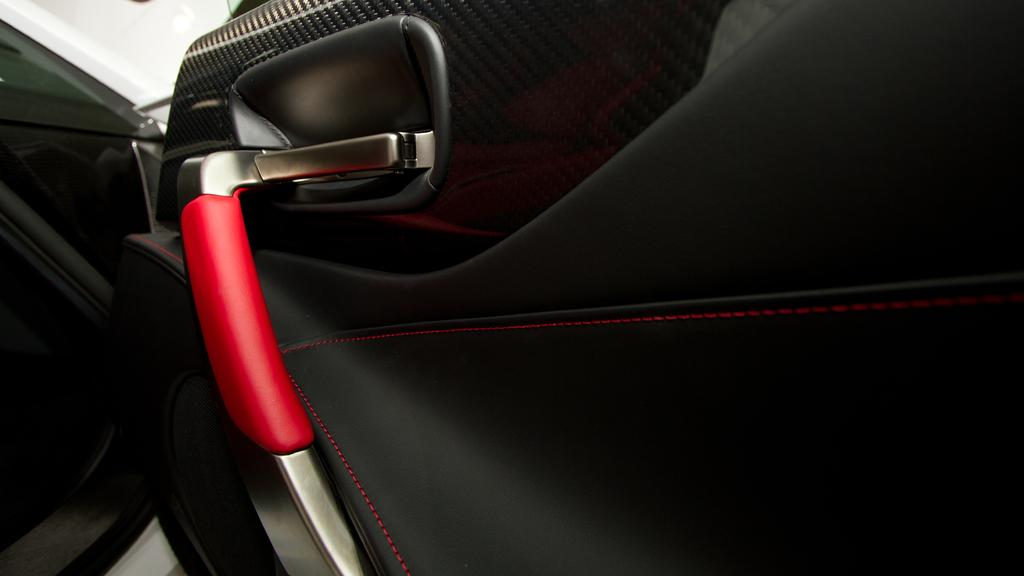What part of a car is shown in the image? There is a car door in the image. What color is the car door? The car door is black. What feature of the car door is red in color? There is a red color handle on the car door. What type of car can be seen on the left side of the image? There is a white color car on the left side of the image. How many zebras are visible in the image? There are no zebras present in the image. What type of collar can be seen on the car door in the image? There is no collar present on the car door in the image. 